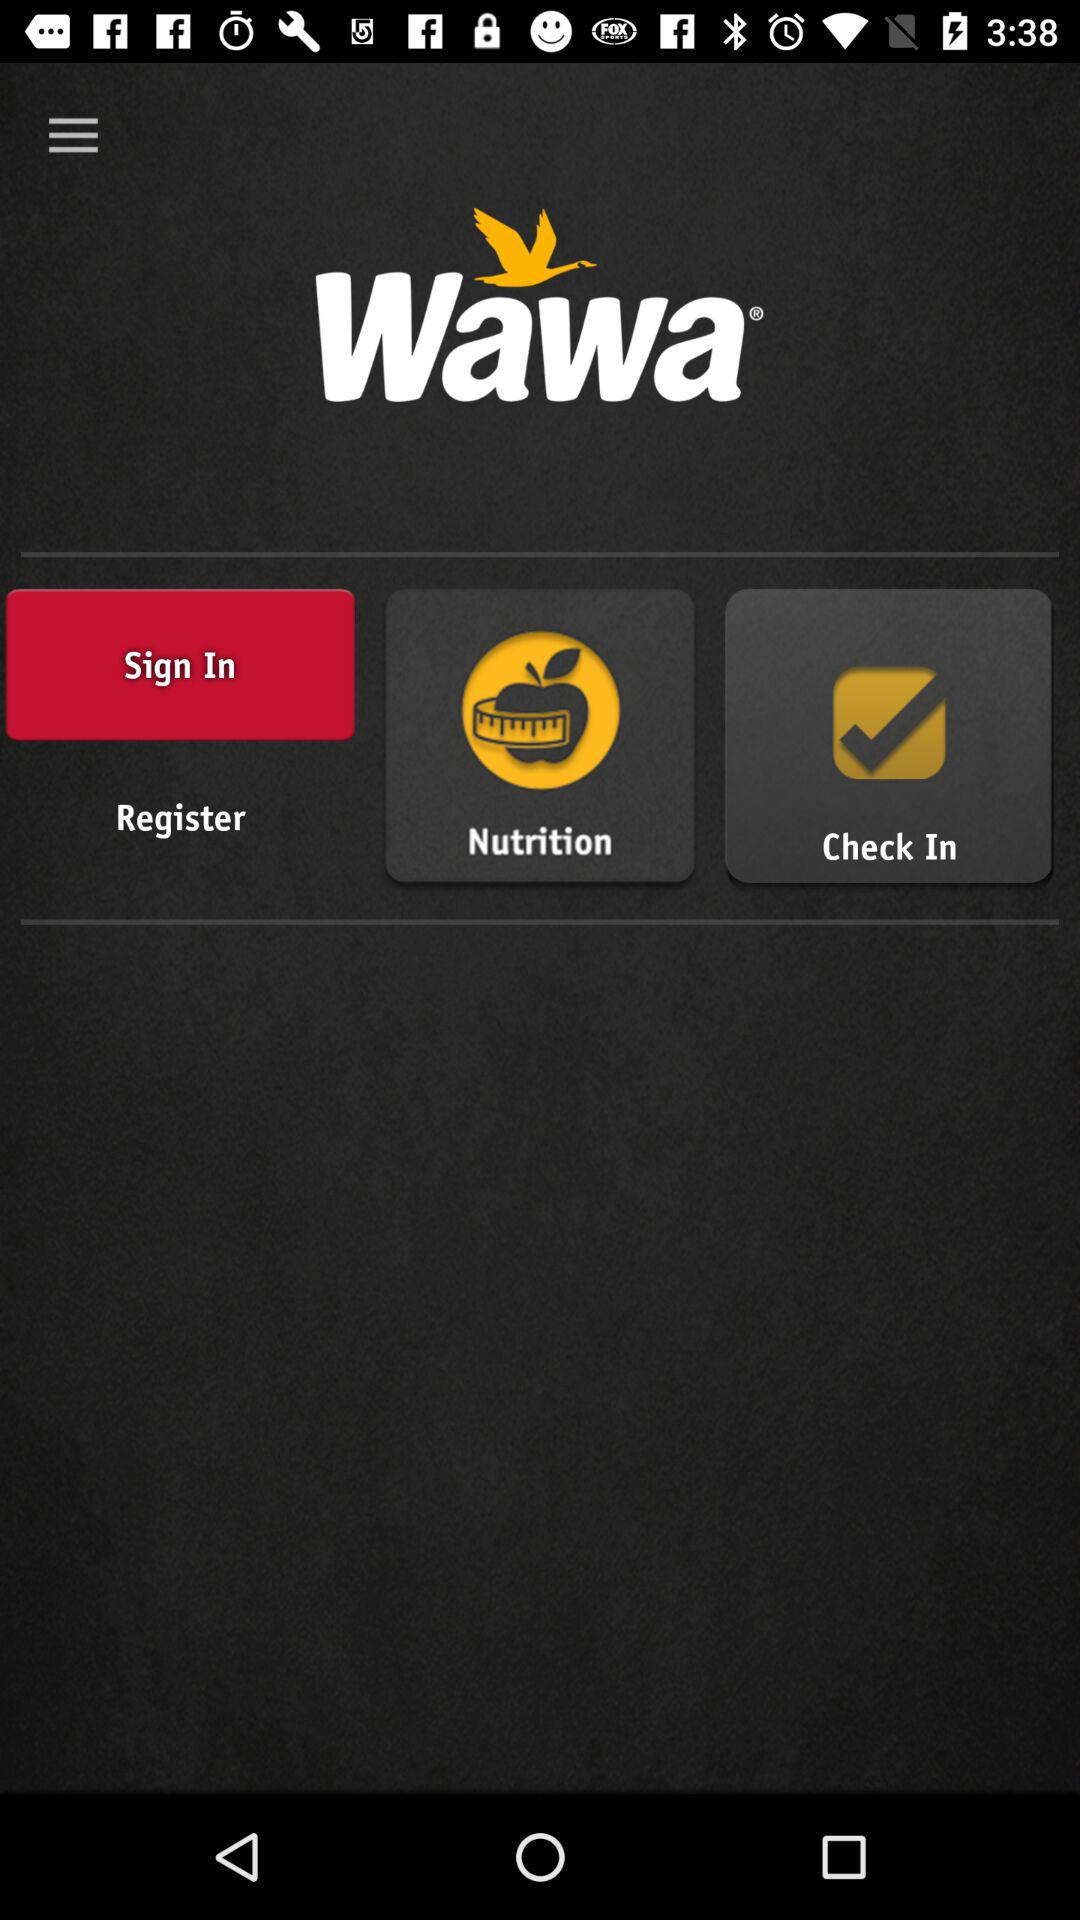What is the name of the application? The name of the application is "Wawa". 